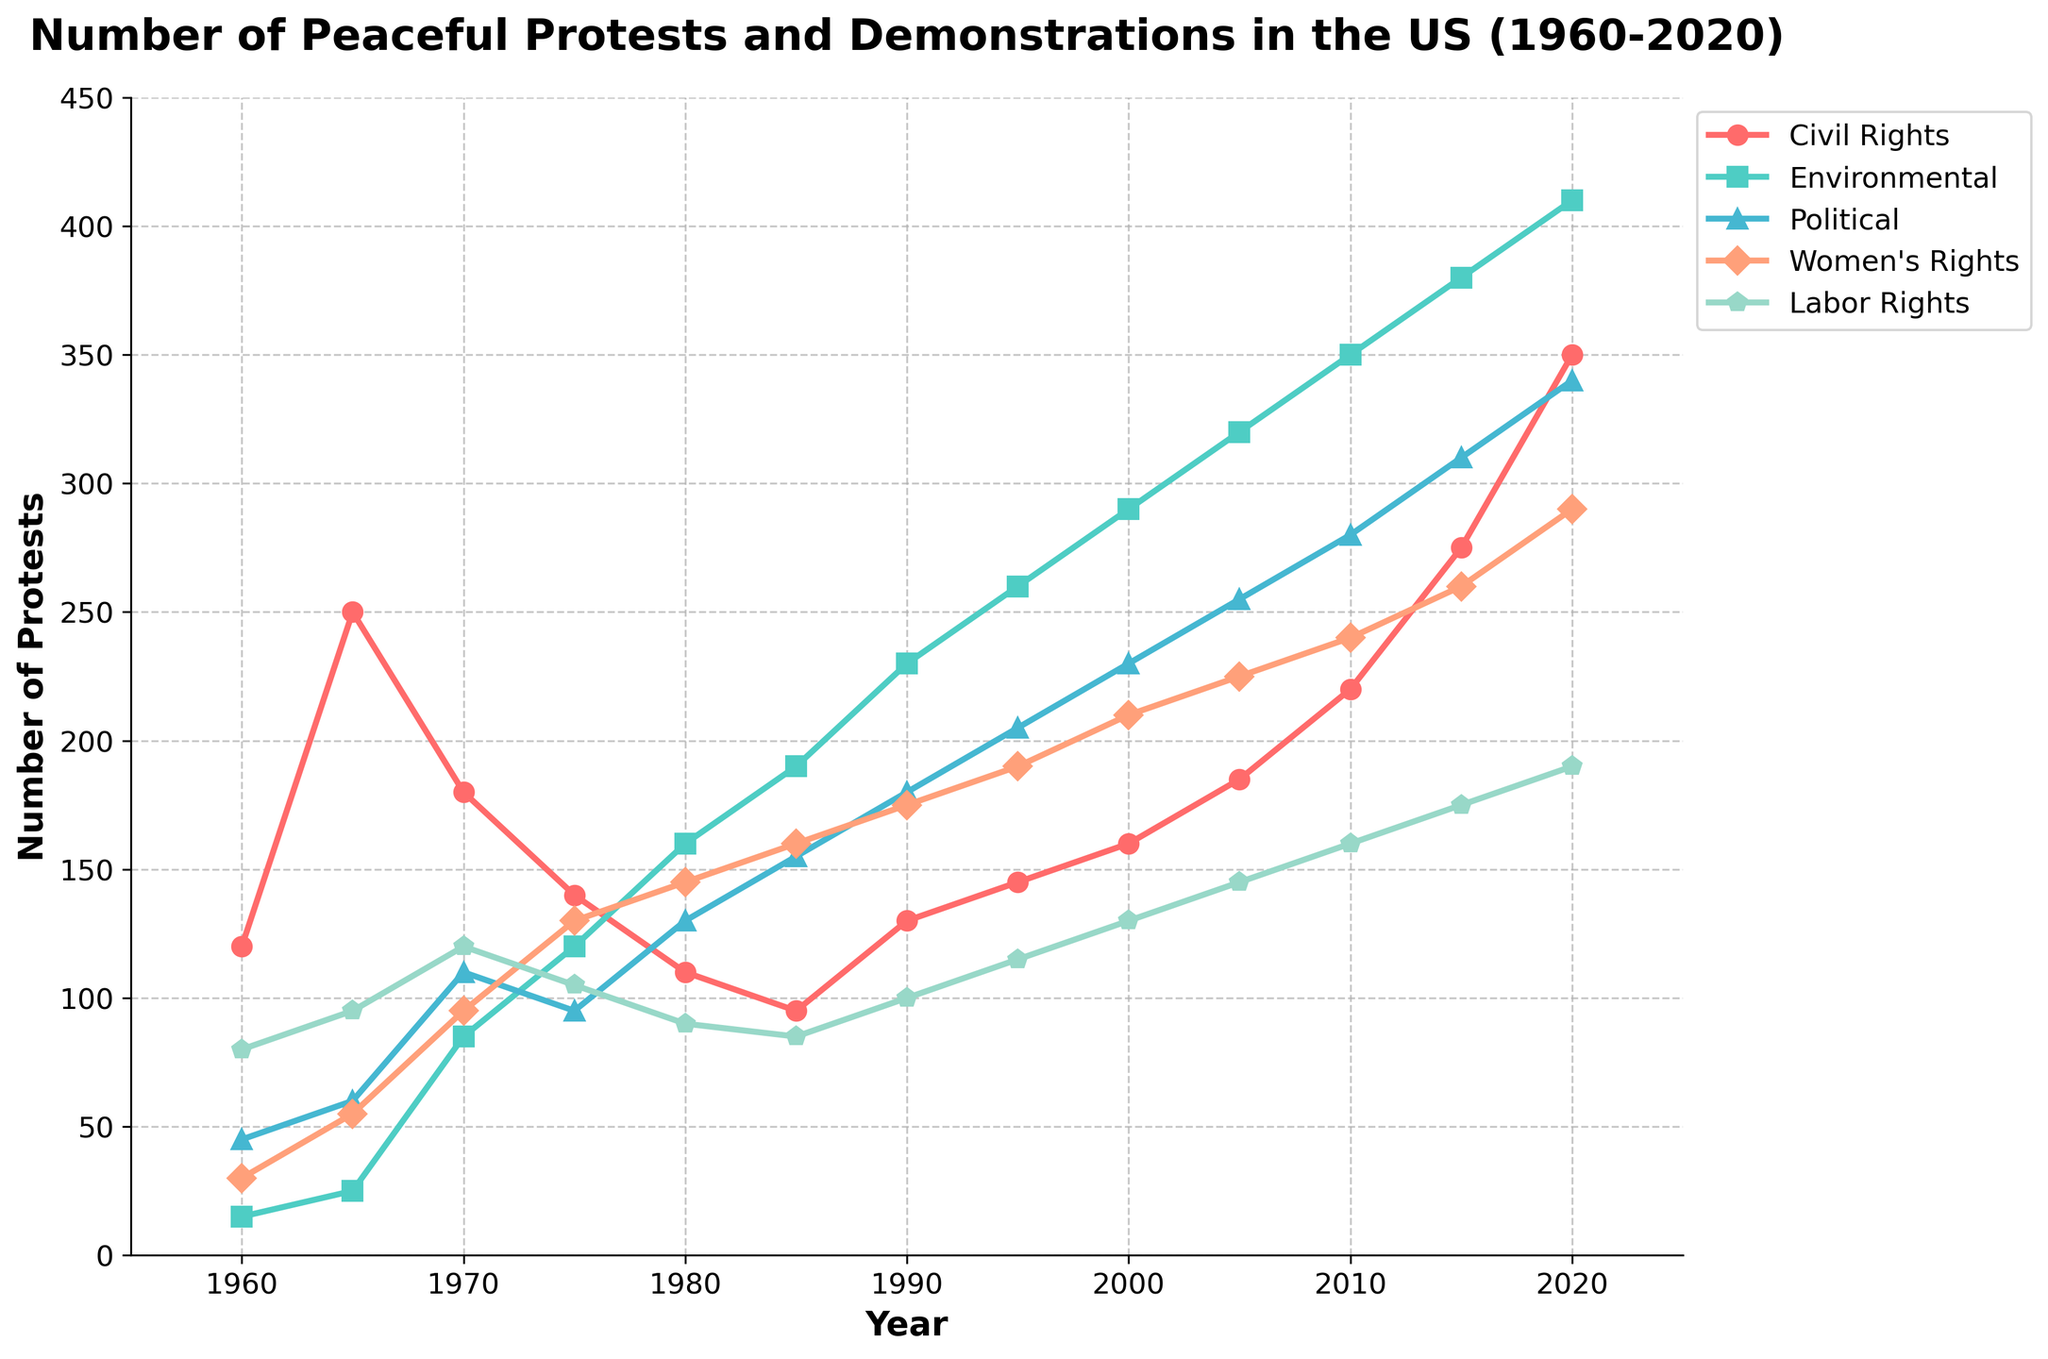How has the number of civil rights protests changed from 1960 to 2020? To find the change in civil rights protests, look at the values for 1960 and 2020. In 1960, there were 120 protests. In 2020, there were 350 protests. The change is 350 - 120 = 230.
Answer: 230 Which cause had the most significant increase in peaceful protests from 1960 to 2020? To determine the most significant increase, compare the data for each cause in 1960 and 2020. Civil Rights: 350-120=230, Environmental: 410-15=395, Political: 340-45=295, Women's Rights: 290-30=260, Labor Rights: 190-80=110. Environmental protests increased the most.
Answer: Environmental What was the difference in the number of political protests between 1980 and 1995? Find the number of political protests in 1980 and 1995. In 1980, there were 130; in 1995, there were 205. The difference is 205 - 130 = 75.
Answer: 75 Which cause had the fewest protests in 1970, and how many were there? Look at the data for 1970: Civil Rights: 180, Environmental: 85, Political: 110, Women's Rights: 95, Labor Rights: 120. Environmental had the fewest with 85.
Answer: Environmental, 85 In which year did the number of women's rights protests surpass 200? Check the data for each year to see when women's rights protests exceeded 200. This occurs for the first time in 1995 with 205 protests.
Answer: 1995 How many total peaceful protests were there in 1990 across all causes? Sum up all the values for 1990: Civil Rights (130) + Environmental (230) + Political (180) + Women's Rights (175) + Labor Rights (100) = 815.
Answer: 815 By how much did environmental protests surpass labor rights protests in 2010? Compare the numbers for 2010: Environmental: 350, Labor Rights: 160. The difference is 350 - 160 = 190.
Answer: 190 Have any causes of protests decreased between any two consecutive decades, and if so, which ones and when? Check each cause between each pair of decades to see if any numbers have decreased. Civil Rights: No, Environmental: No, Political: No, Women's Rights: No, Labor Rights from 1970 (120) to 1980 (90).
Answer: Labor Rights, 1970 to 1980 What was the average number of environmental protests per decade from 1960 to 2020? Average calculation requires summing values and dividing by number of decades: (15 + 25 + 85 + 120 + 160 + 190 + 230 + 260 + 290 + 320 + 350 + 380 + 410) / 13 = 2630 / 13 = 202.31.
Answer: 202.31 